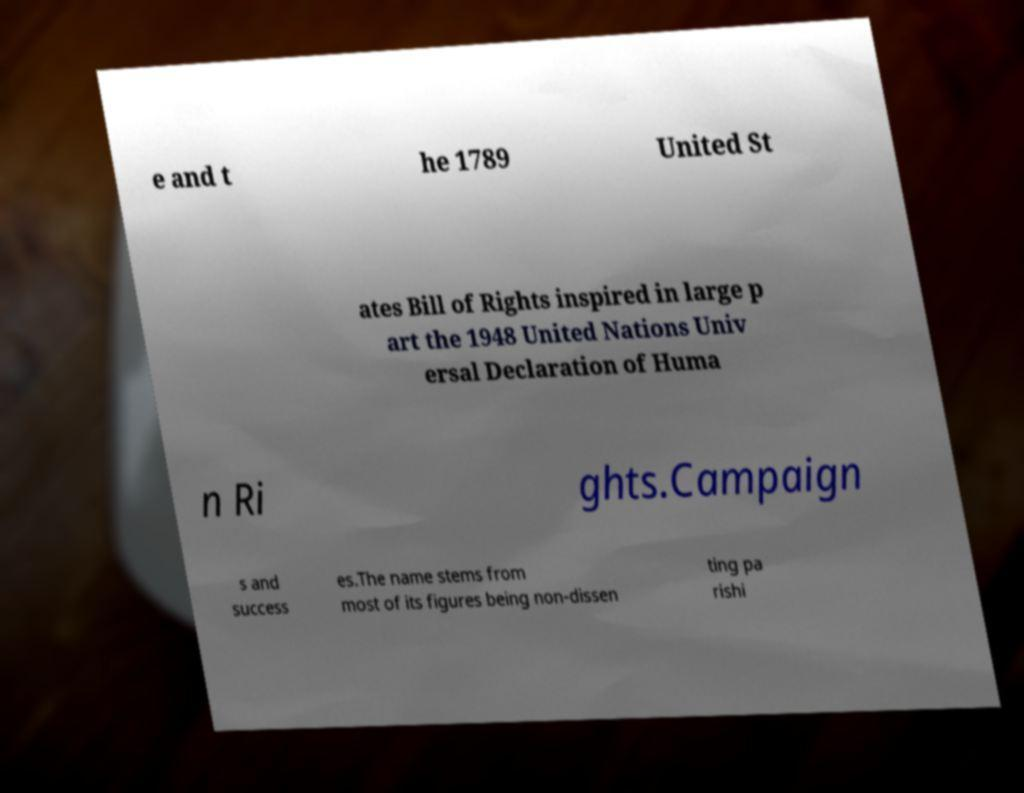Can you accurately transcribe the text from the provided image for me? e and t he 1789 United St ates Bill of Rights inspired in large p art the 1948 United Nations Univ ersal Declaration of Huma n Ri ghts.Campaign s and success es.The name stems from most of its figures being non-dissen ting pa rishi 